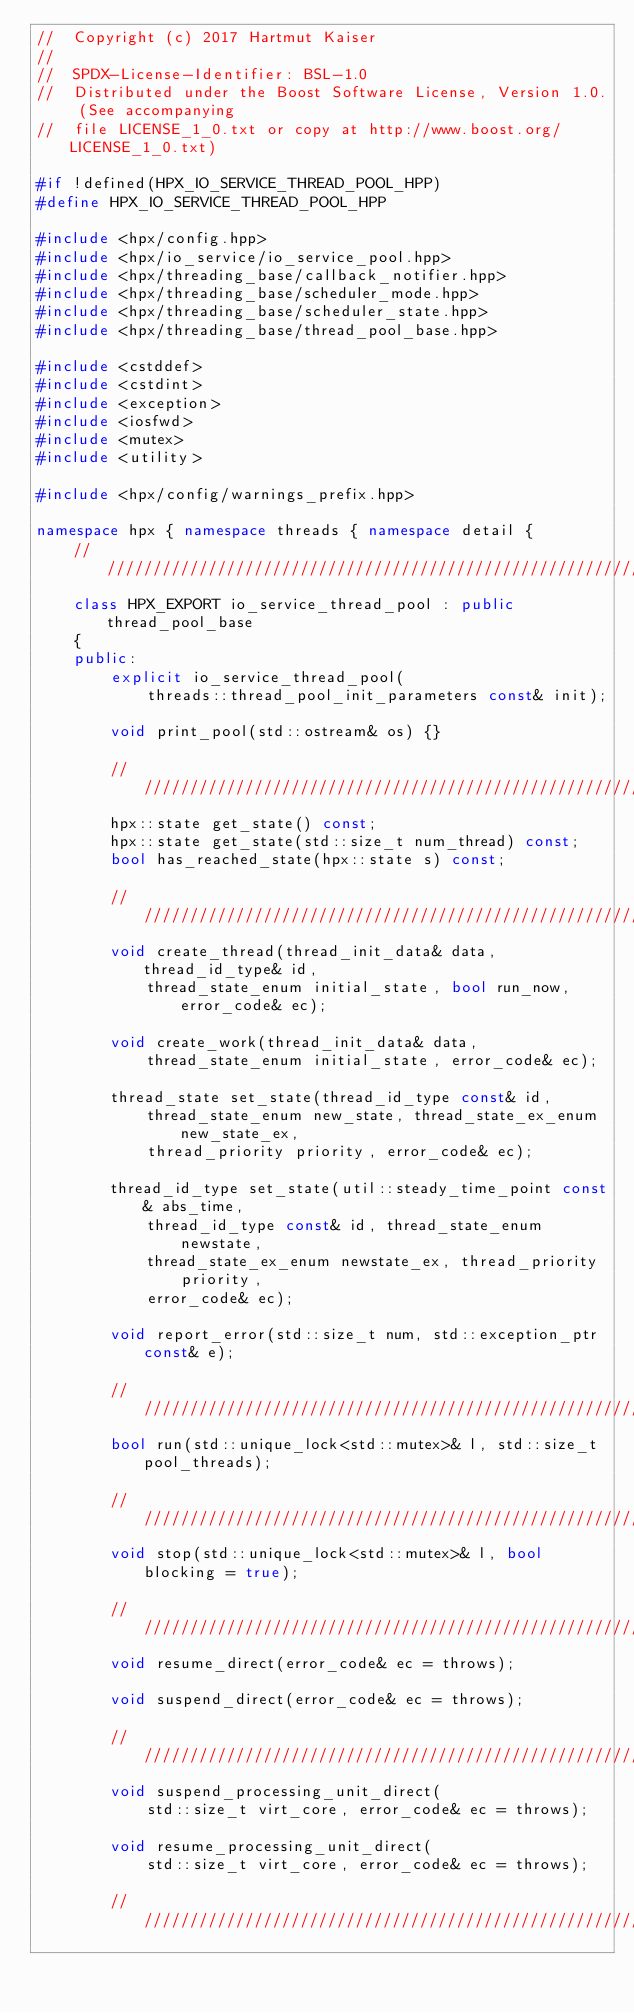Convert code to text. <code><loc_0><loc_0><loc_500><loc_500><_C++_>//  Copyright (c) 2017 Hartmut Kaiser
//
//  SPDX-License-Identifier: BSL-1.0
//  Distributed under the Boost Software License, Version 1.0. (See accompanying
//  file LICENSE_1_0.txt or copy at http://www.boost.org/LICENSE_1_0.txt)

#if !defined(HPX_IO_SERVICE_THREAD_POOL_HPP)
#define HPX_IO_SERVICE_THREAD_POOL_HPP

#include <hpx/config.hpp>
#include <hpx/io_service/io_service_pool.hpp>
#include <hpx/threading_base/callback_notifier.hpp>
#include <hpx/threading_base/scheduler_mode.hpp>
#include <hpx/threading_base/scheduler_state.hpp>
#include <hpx/threading_base/thread_pool_base.hpp>

#include <cstddef>
#include <cstdint>
#include <exception>
#include <iosfwd>
#include <mutex>
#include <utility>

#include <hpx/config/warnings_prefix.hpp>

namespace hpx { namespace threads { namespace detail {
    ///////////////////////////////////////////////////////////////////////////
    class HPX_EXPORT io_service_thread_pool : public thread_pool_base
    {
    public:
        explicit io_service_thread_pool(
            threads::thread_pool_init_parameters const& init);

        void print_pool(std::ostream& os) {}

        ///////////////////////////////////////////////////////////////////////
        hpx::state get_state() const;
        hpx::state get_state(std::size_t num_thread) const;
        bool has_reached_state(hpx::state s) const;

        ///////////////////////////////////////////////////////////////////////
        void create_thread(thread_init_data& data, thread_id_type& id,
            thread_state_enum initial_state, bool run_now, error_code& ec);

        void create_work(thread_init_data& data,
            thread_state_enum initial_state, error_code& ec);

        thread_state set_state(thread_id_type const& id,
            thread_state_enum new_state, thread_state_ex_enum new_state_ex,
            thread_priority priority, error_code& ec);

        thread_id_type set_state(util::steady_time_point const& abs_time,
            thread_id_type const& id, thread_state_enum newstate,
            thread_state_ex_enum newstate_ex, thread_priority priority,
            error_code& ec);

        void report_error(std::size_t num, std::exception_ptr const& e);

        ///////////////////////////////////////////////////////////////////////
        bool run(std::unique_lock<std::mutex>& l, std::size_t pool_threads);

        ///////////////////////////////////////////////////////////////////////
        void stop(std::unique_lock<std::mutex>& l, bool blocking = true);

        ///////////////////////////////////////////////////////////////////////
        void resume_direct(error_code& ec = throws);

        void suspend_direct(error_code& ec = throws);

        ///////////////////////////////////////////////////////////////////////
        void suspend_processing_unit_direct(
            std::size_t virt_core, error_code& ec = throws);

        void resume_processing_unit_direct(
            std::size_t virt_core, error_code& ec = throws);

        ///////////////////////////////////////////////////////////////////////</code> 